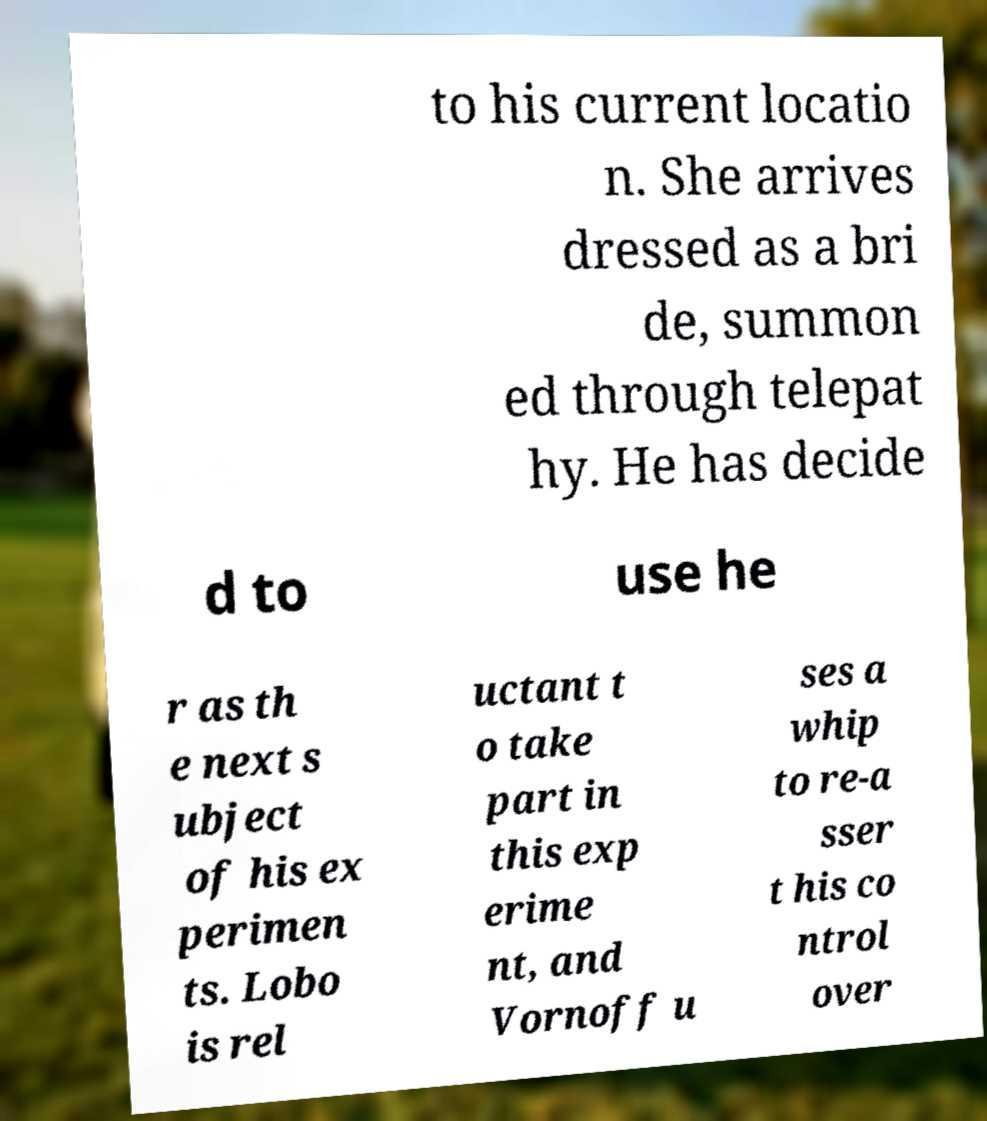I need the written content from this picture converted into text. Can you do that? to his current locatio n. She arrives dressed as a bri de, summon ed through telepat hy. He has decide d to use he r as th e next s ubject of his ex perimen ts. Lobo is rel uctant t o take part in this exp erime nt, and Vornoff u ses a whip to re-a sser t his co ntrol over 